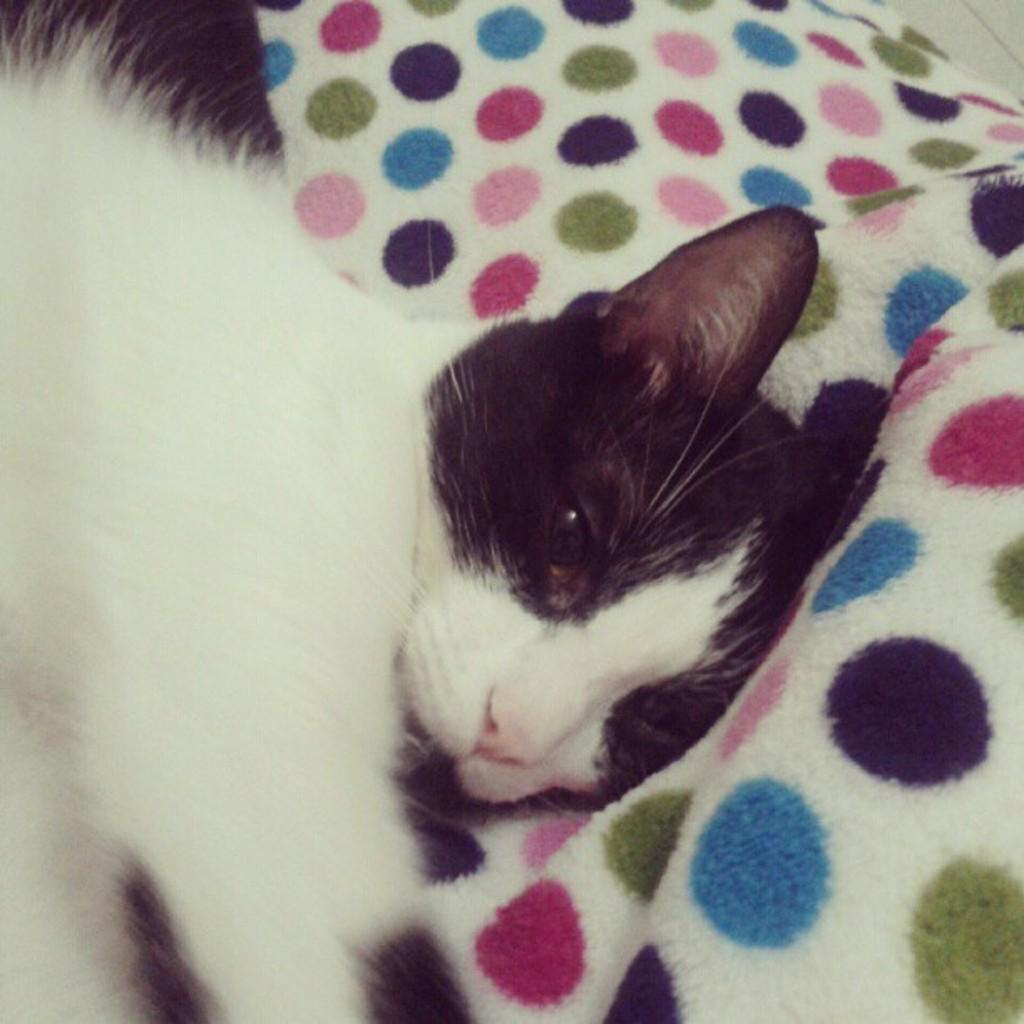What type of animal is in the image? There is a cat in the image. What is the cat doing in the image? The cat is lying on a blanket. What type of rifle is the cat holding in the image? There is no rifle present in the image; the cat is simply lying on a blanket. 